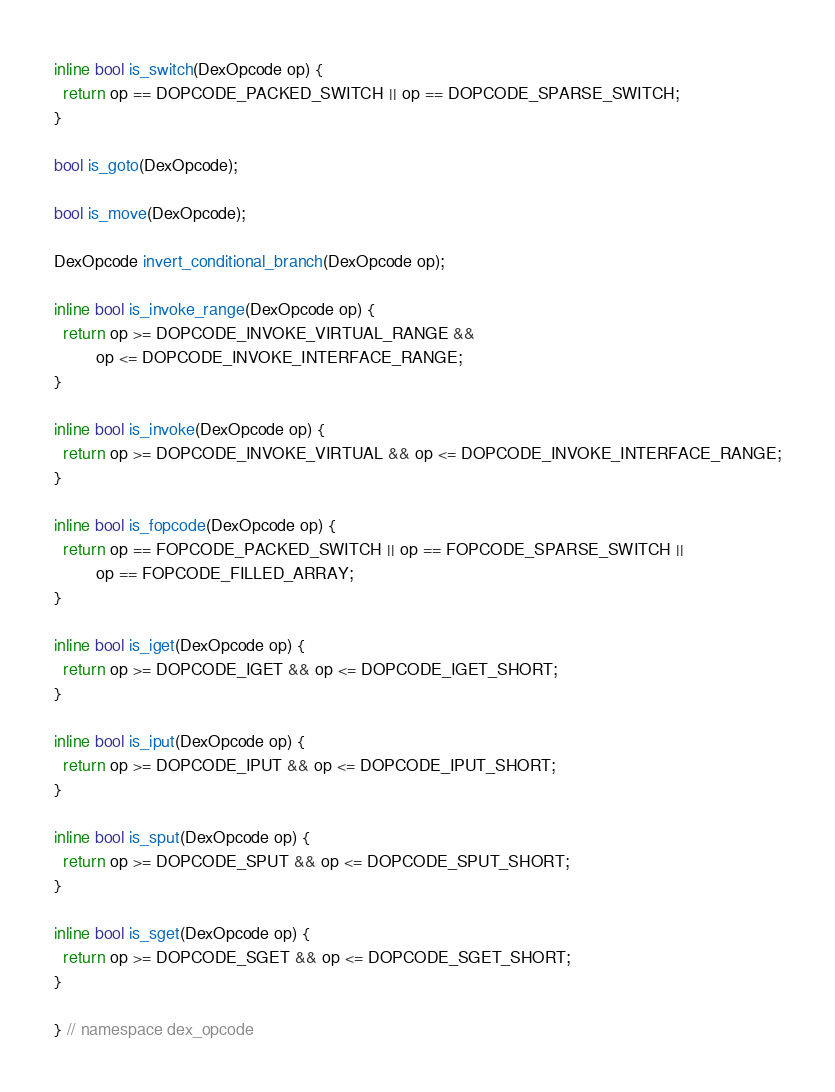Convert code to text. <code><loc_0><loc_0><loc_500><loc_500><_C_>inline bool is_switch(DexOpcode op) {
  return op == DOPCODE_PACKED_SWITCH || op == DOPCODE_SPARSE_SWITCH;
}

bool is_goto(DexOpcode);

bool is_move(DexOpcode);

DexOpcode invert_conditional_branch(DexOpcode op);

inline bool is_invoke_range(DexOpcode op) {
  return op >= DOPCODE_INVOKE_VIRTUAL_RANGE &&
         op <= DOPCODE_INVOKE_INTERFACE_RANGE;
}

inline bool is_invoke(DexOpcode op) {
  return op >= DOPCODE_INVOKE_VIRTUAL && op <= DOPCODE_INVOKE_INTERFACE_RANGE;
}

inline bool is_fopcode(DexOpcode op) {
  return op == FOPCODE_PACKED_SWITCH || op == FOPCODE_SPARSE_SWITCH ||
         op == FOPCODE_FILLED_ARRAY;
}

inline bool is_iget(DexOpcode op) {
  return op >= DOPCODE_IGET && op <= DOPCODE_IGET_SHORT;
}

inline bool is_iput(DexOpcode op) {
  return op >= DOPCODE_IPUT && op <= DOPCODE_IPUT_SHORT;
}

inline bool is_sput(DexOpcode op) {
  return op >= DOPCODE_SPUT && op <= DOPCODE_SPUT_SHORT;
}

inline bool is_sget(DexOpcode op) {
  return op >= DOPCODE_SGET && op <= DOPCODE_SGET_SHORT;
}

} // namespace dex_opcode
</code> 